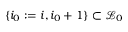Convert formula to latex. <formula><loc_0><loc_0><loc_500><loc_500>\{ i _ { 0 } \colon = i , i _ { 0 } + 1 \} \subset \mathcal { L } _ { 0 }</formula> 